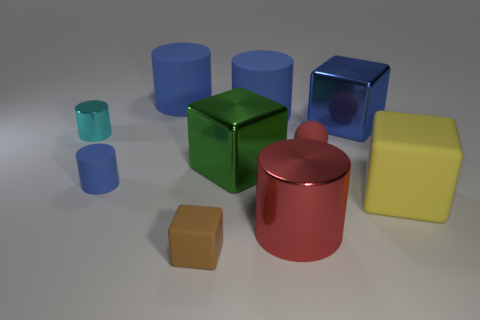There is a brown thing; does it have the same size as the shiny cylinder that is in front of the red sphere?
Make the answer very short. No. The large rubber object that is on the left side of the green object has what shape?
Your response must be concise. Cylinder. Is there anything else that has the same material as the tiny cyan object?
Your answer should be very brief. Yes. Are there more big yellow matte things that are behind the big blue metallic object than matte objects?
Offer a terse response. No. There is a big green metal thing on the right side of the blue thing in front of the small red thing; how many blocks are behind it?
Keep it short and to the point. 1. Does the metallic cylinder left of the big green shiny cube have the same size as the blue cylinder in front of the big green block?
Keep it short and to the point. Yes. What material is the small thing that is to the right of the cylinder that is in front of the big matte cube made of?
Your answer should be compact. Rubber. How many things are things that are on the left side of the tiny blue rubber cylinder or small rubber things?
Provide a succinct answer. 4. Are there the same number of tiny cyan objects that are left of the rubber sphere and big blue cylinders in front of the red cylinder?
Offer a very short reply. No. What is the blue cylinder right of the rubber cube in front of the large red thing left of the tiny red thing made of?
Ensure brevity in your answer.  Rubber. 